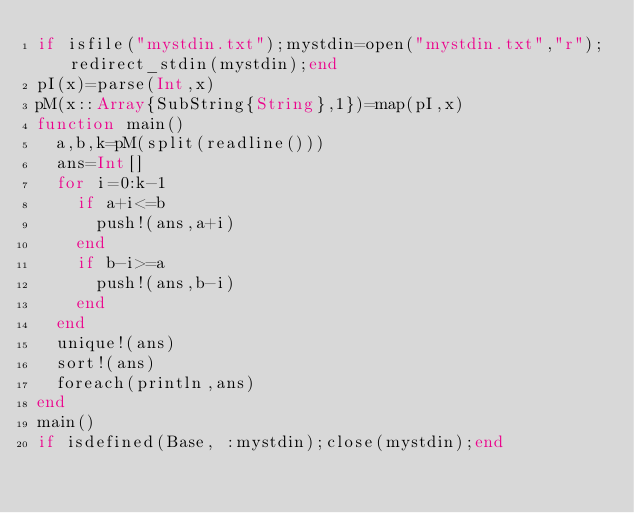Convert code to text. <code><loc_0><loc_0><loc_500><loc_500><_Julia_>if isfile("mystdin.txt");mystdin=open("mystdin.txt","r");redirect_stdin(mystdin);end
pI(x)=parse(Int,x)
pM(x::Array{SubString{String},1})=map(pI,x)
function main()
  a,b,k=pM(split(readline()))
  ans=Int[]
  for i=0:k-1
    if a+i<=b
      push!(ans,a+i)
    end
    if b-i>=a
      push!(ans,b-i)
    end
  end
  unique!(ans)
  sort!(ans)
  foreach(println,ans)
end
main()
if isdefined(Base, :mystdin);close(mystdin);end</code> 